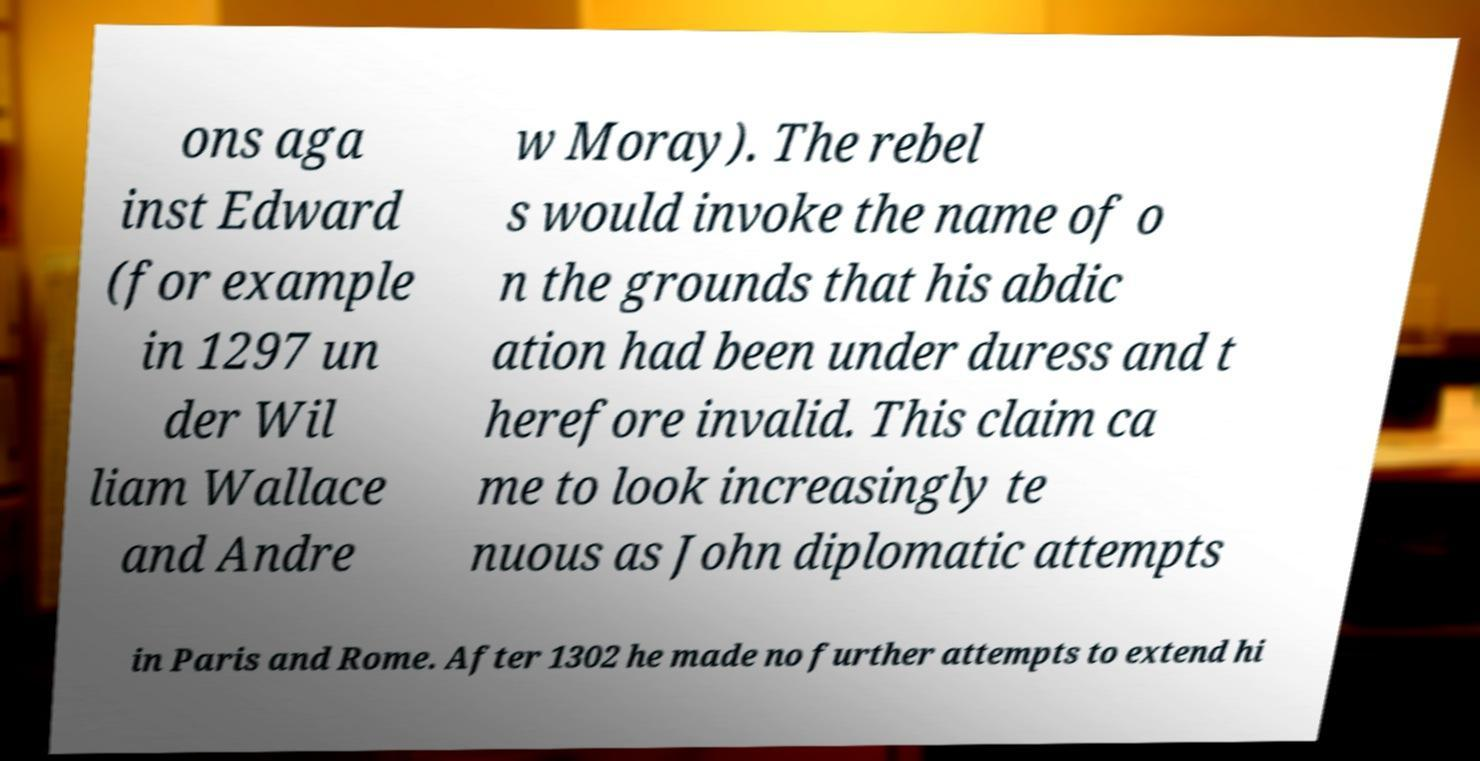Please read and relay the text visible in this image. What does it say? ons aga inst Edward (for example in 1297 un der Wil liam Wallace and Andre w Moray). The rebel s would invoke the name of o n the grounds that his abdic ation had been under duress and t herefore invalid. This claim ca me to look increasingly te nuous as John diplomatic attempts in Paris and Rome. After 1302 he made no further attempts to extend hi 